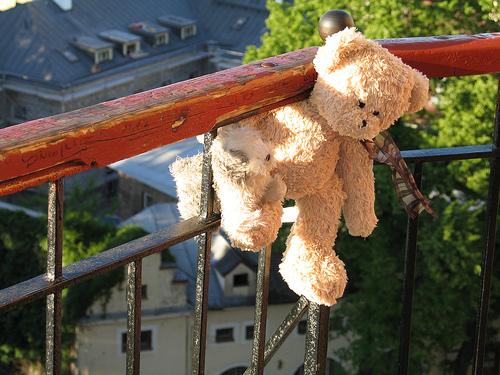Where is the bear?
Answer briefly. Railing. Why is the bear on the road like that?
Be succinct. Stuck. What color is the bear?
Quick response, please. Brown. 